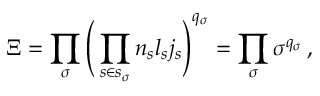Convert formula to latex. <formula><loc_0><loc_0><loc_500><loc_500>\Xi = \prod _ { \sigma } \left ( \prod _ { s \in s _ { \sigma } } n _ { s } l _ { s } j _ { s } \right ) ^ { q _ { \sigma } } = \prod _ { \sigma } \sigma ^ { q _ { \sigma } } \, ,</formula> 